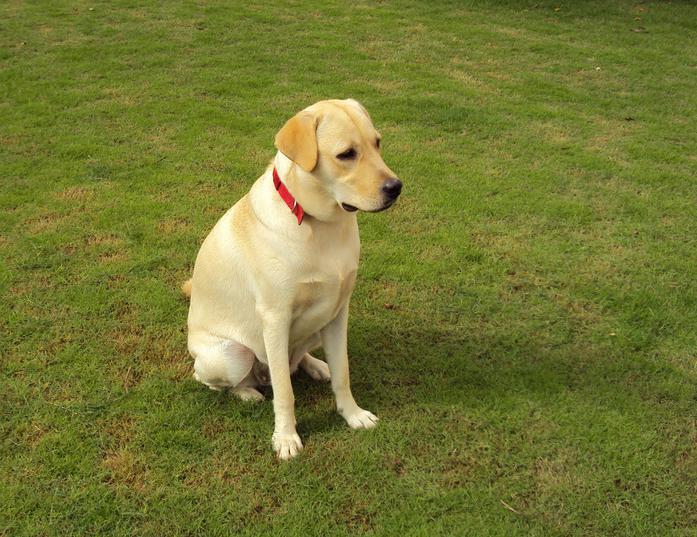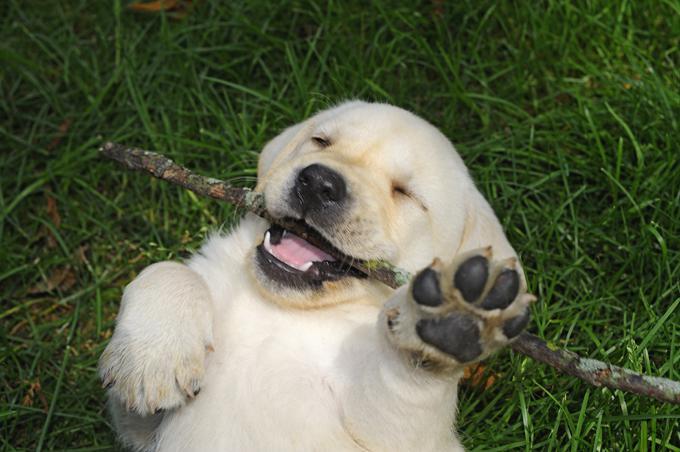The first image is the image on the left, the second image is the image on the right. For the images displayed, is the sentence "One dog has at least two paws on cement." factually correct? Answer yes or no. No. 